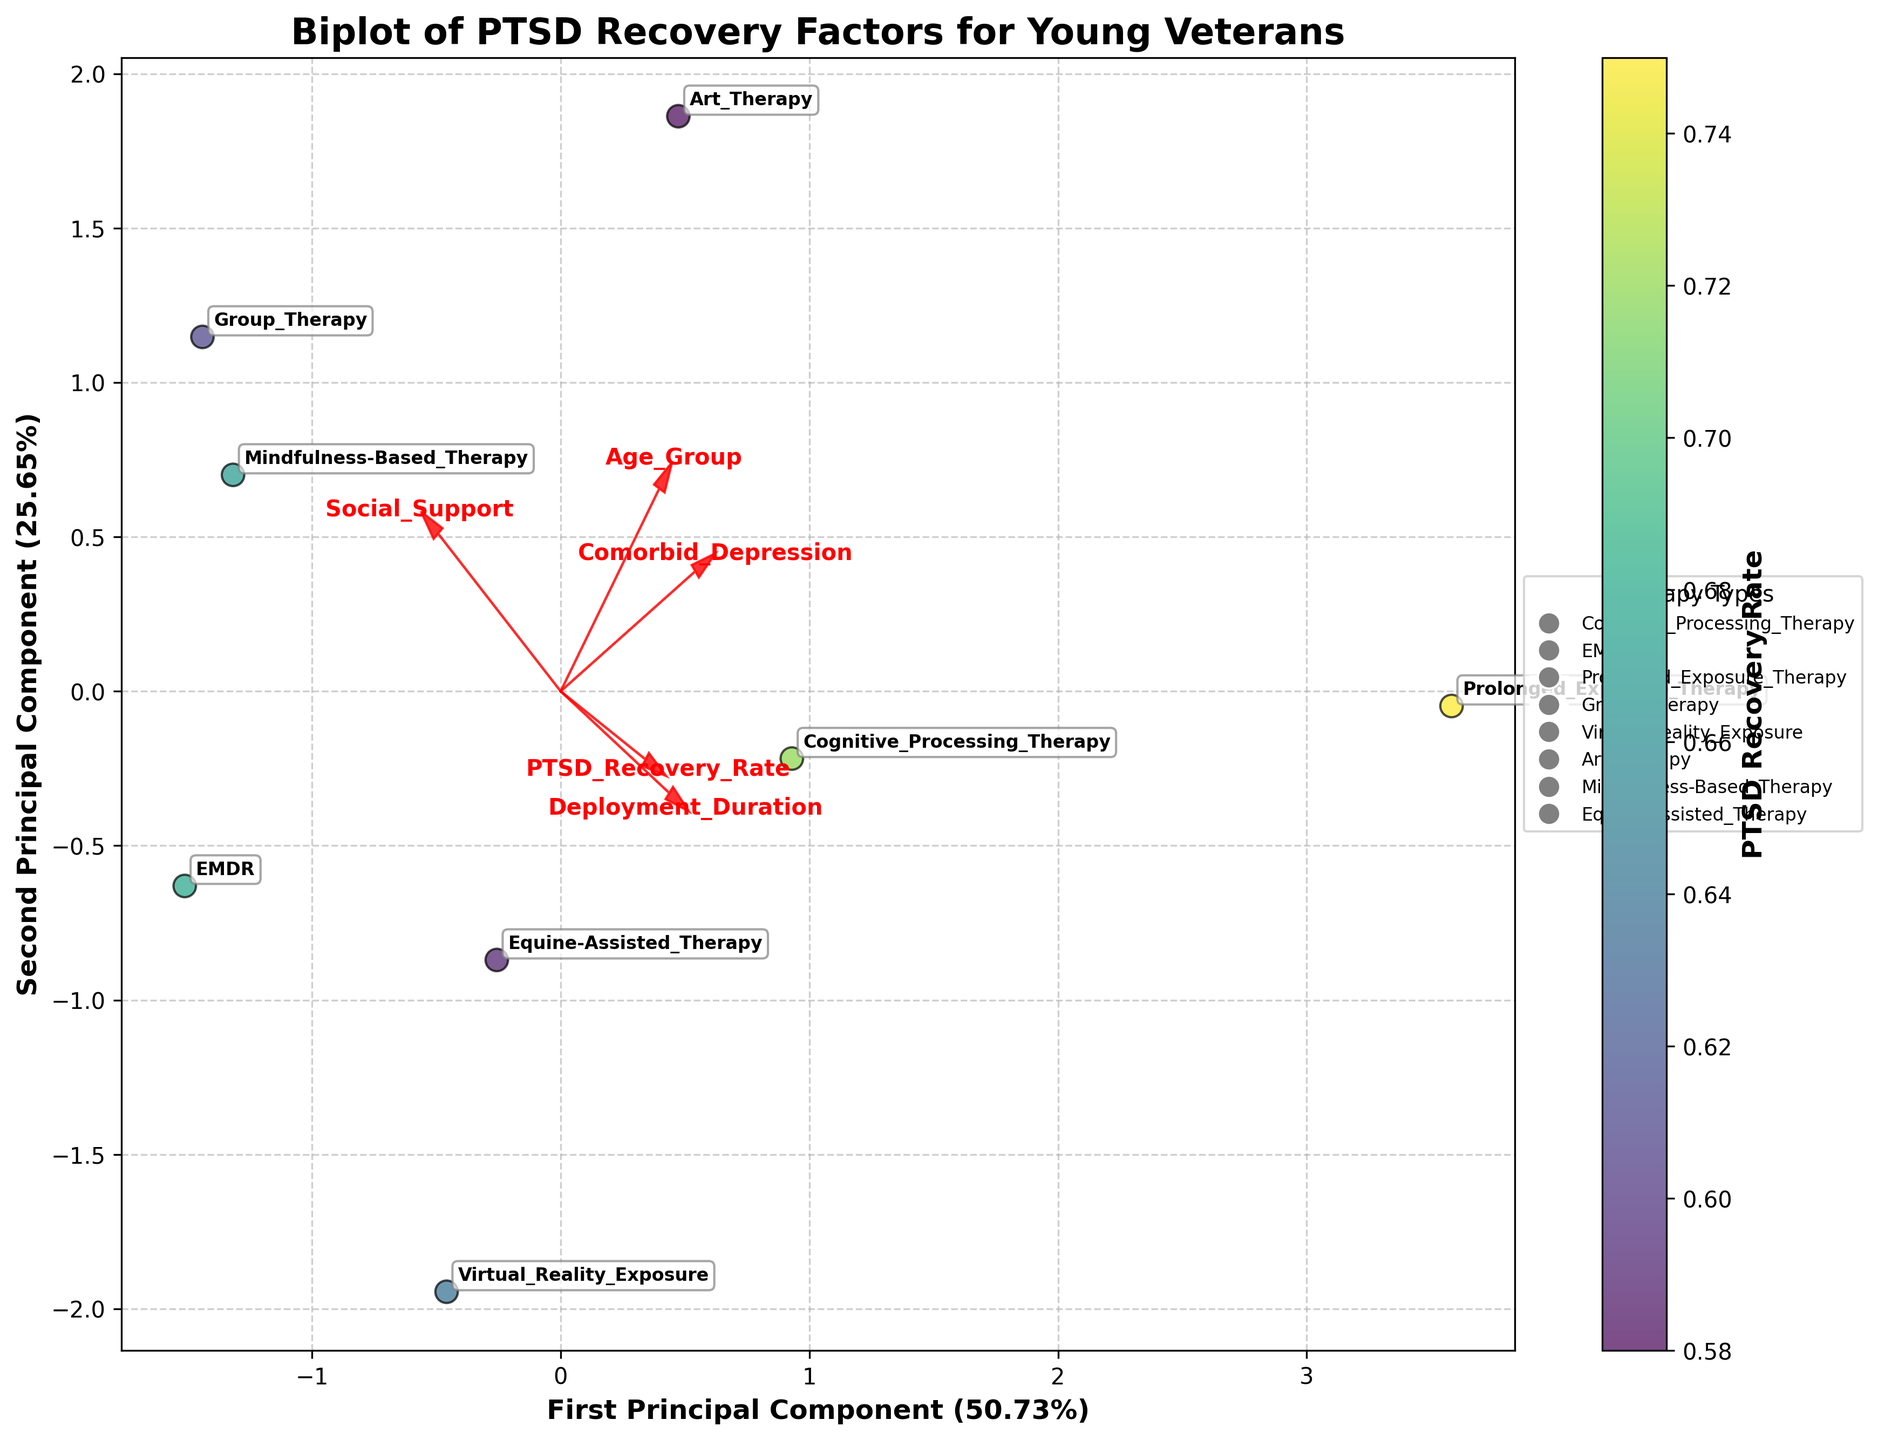What is the title of the figure? The title is shown at the top of the plot. It provides an overview of what the figure represents.
Answer: Biplot of PTSD Recovery Factors for Young Veterans Which therapy type has the highest PTSD recovery rate? Check the data points on the plot and look for the data point with the highest color intensity in the colorbar indicating the recovery rate. Annotate with the therapy type.
Answer: Prolonged Exposure Therapy How does the age group of 25-30 generally correlate with PTSD recovery rates based on the plot? Observe the positions of the data points labeled as from "25-30" on the plot and check their corresponding recovery rates using the colorbar.
Answer: Data points in this age group generally show higher recovery rates, as indicated by lighter colors Which features are most positively correlated with PTSD recovery rates? Identify arrows emanating from the origin in the direction most closely aligned with higher recovery rates, typically shown by their positioning and length.
Answer: Age Group and Social Support What therapy type has the lowest social support score, and what is its corresponding recovery rate? Locate the features on the plot, identify points associated with low social support on the x-axis, then check their recovery rates using the colorbar.
Answer: Virtual Reality Exposure, 0.64 How does the deployment duration affect PTSD recovery rates? Length of deployment duration is axis-aligned with a certain direction; view the alignment of data points based on this feature and related recovery rates.
Answer: Longer deployment duration generally correlates with lower recovery rates Which therapy type caters predominantly to veterans aged 20-25? Check data labels and observe age group markers next to each point. Identify those specifically annotated with "20-25".
Answer: EMDR and Virtual Reality Exposure Are there any therapy types that have both high comorbid depression and high social support scores? Examine the plot for data points positioned high along both the comorbid depression axis and social support vector and cross-verify their scores.
Answer: Art Therapy How does cognitive processing therapy (CPT) compare to equine-assisted therapy (EAT) in terms of PTSD recovery rate? Locate and compare the placement and color intensity of these two specific data points on the plot.
Answer: CPT is higher (0.72) than EAT (0.59) How well do Mindfulness-based therapy and Group therapy perform in terms of PTSD Recovery? Identify the positions of these therapies on the plot and refer to the colorbar for their recovery rates.
Answer: Both perform moderately, with rates of 0.67 for Mindfulness-based and 0.61 for Group therapy 